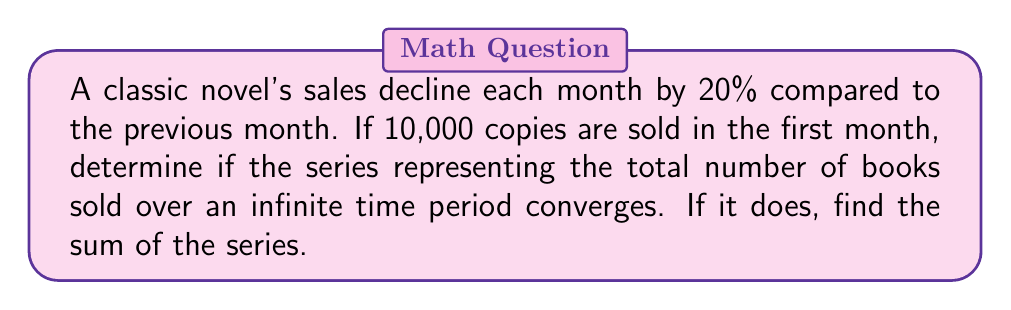Can you answer this question? Let's approach this step-by-step:

1) First, we need to identify the geometric series. The first term $a = 10000$, and the common ratio $r = 0.8$ (since sales decline by 20%, or 0.2, each month, 1 - 0.2 = 0.8).

2) The general form of a geometric series is:

   $$S_{\infty} = a + ar + ar^2 + ar^3 + ...$$

3) For a geometric series to converge, the absolute value of the common ratio must be less than 1:

   $$|r| < 1$$

4) In this case, $|r| = |0.8| = 0.8$, which is indeed less than 1. Therefore, the series converges.

5) For a converging geometric series, the sum to infinity is given by the formula:

   $$S_{\infty} = \frac{a}{1-r}$$

6) Substituting our values:

   $$S_{\infty} = \frac{10000}{1-0.8} = \frac{10000}{0.2} = 50000$$

Therefore, the series converges, and the total number of books sold over an infinite time period is 50,000.
Answer: Converges; Sum = 50,000 books 